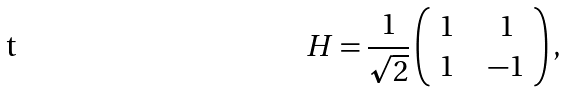<formula> <loc_0><loc_0><loc_500><loc_500>H = \frac { 1 } { \sqrt { 2 } } \left ( \begin{array} { c l c r } 1 & & 1 \\ 1 & & - 1 \end{array} \right ) ,</formula> 